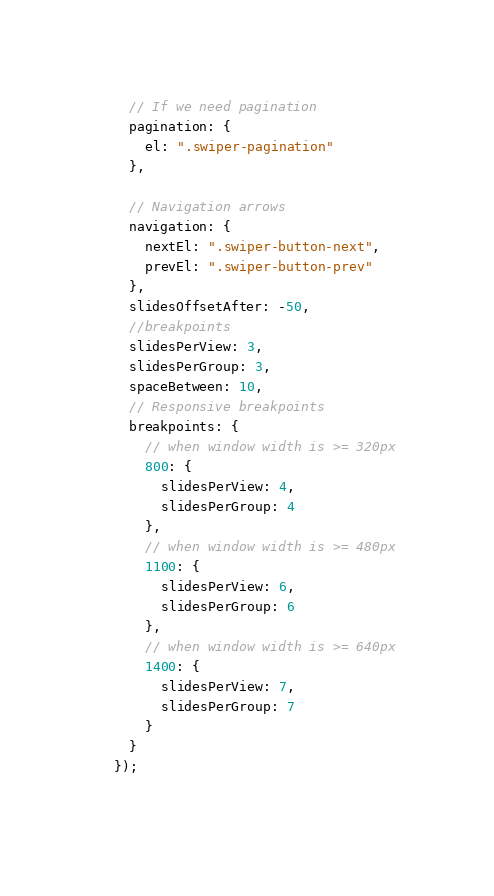Convert code to text. <code><loc_0><loc_0><loc_500><loc_500><_JavaScript_>    // If we need pagination
    pagination: {
      el: ".swiper-pagination"
    },
  
    // Navigation arrows
    navigation: {
      nextEl: ".swiper-button-next",
      prevEl: ".swiper-button-prev"
    },
    slidesOffsetAfter: -50,
    //breakpoints
    slidesPerView: 3,
    slidesPerGroup: 3,
    spaceBetween: 10,
    // Responsive breakpoints
    breakpoints: {
      // when window width is >= 320px
      800: {
        slidesPerView: 4,
        slidesPerGroup: 4
      },
      // when window width is >= 480px
      1100: {
        slidesPerView: 6,
        slidesPerGroup: 6
      },
      // when window width is >= 640px
      1400: {
        slidesPerView: 7,
        slidesPerGroup: 7
      }
    }
  });
  </code> 